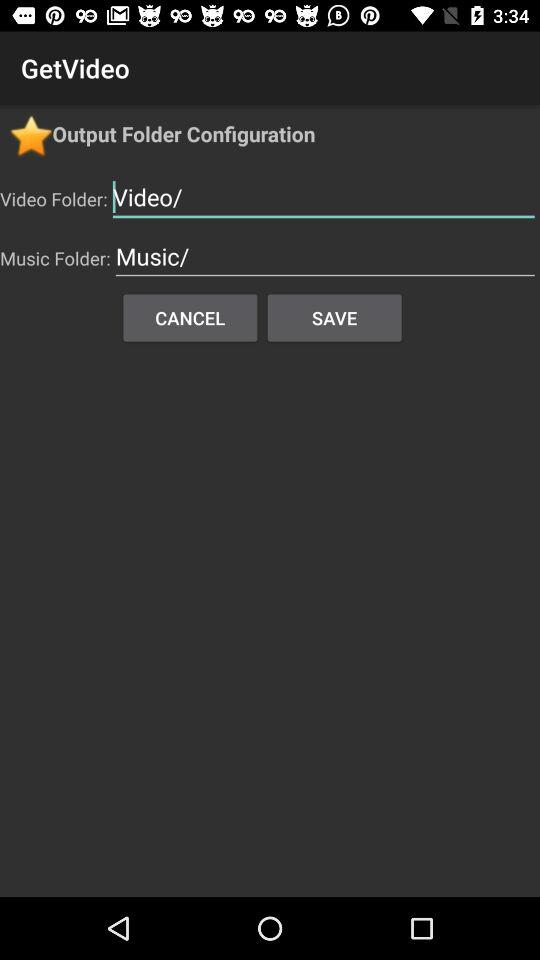What is the application name? The application shown in the image is called 'GetVideo'. It appears to be a mobile app designed for managing and storing video files. The interface shown includes options for configuring 'Video Folder' and 'Music Folder', suggesting it might allow users to organize and access their media files efficiently. 